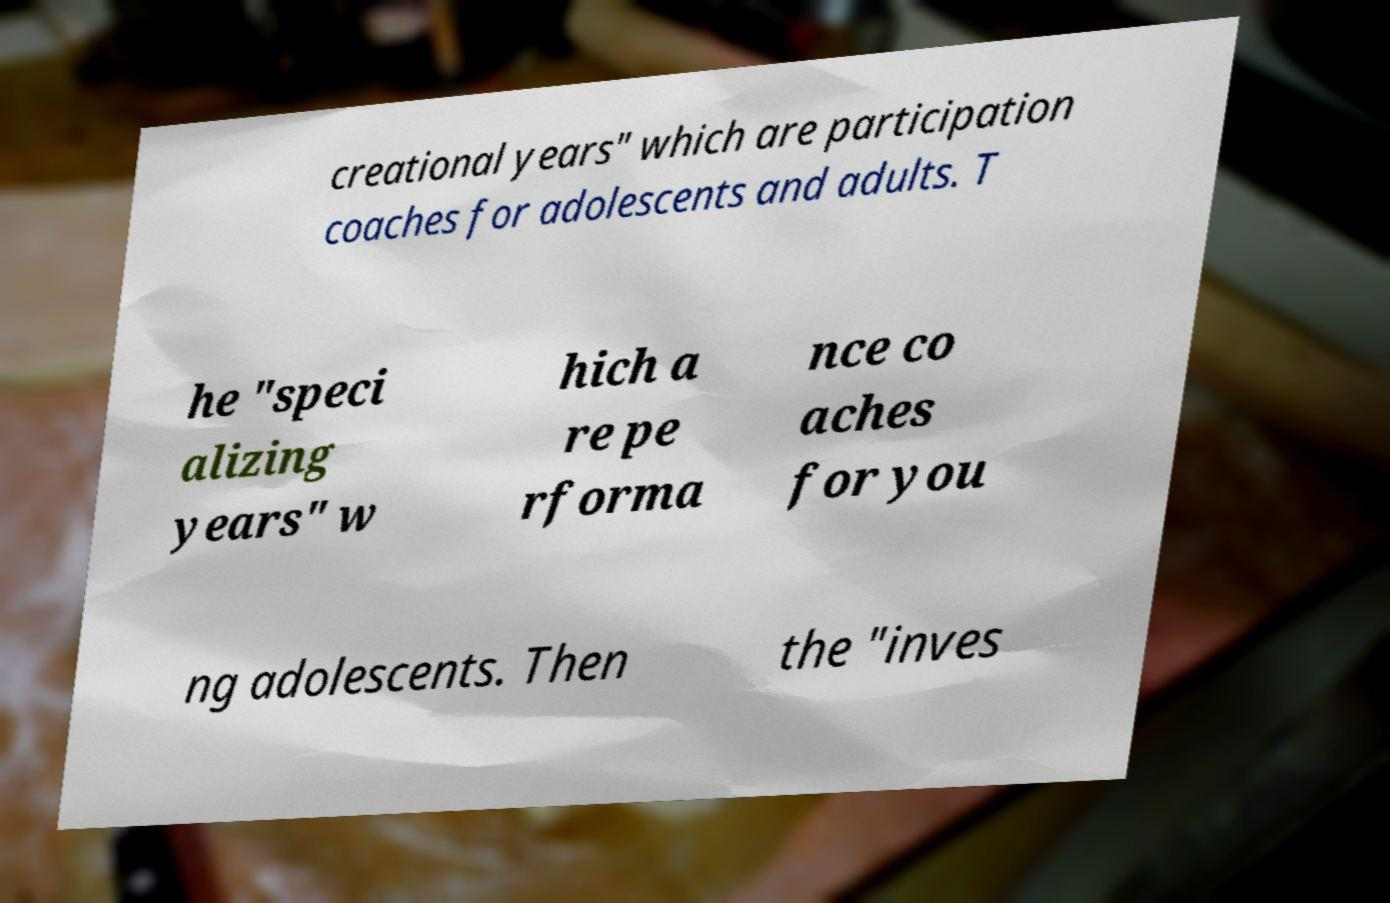Please read and relay the text visible in this image. What does it say? creational years" which are participation coaches for adolescents and adults. T he "speci alizing years" w hich a re pe rforma nce co aches for you ng adolescents. Then the "inves 